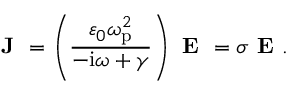<formula> <loc_0><loc_0><loc_500><loc_500>J = \left ( \frac { \varepsilon _ { 0 } \omega _ { p } ^ { 2 } } { - i \omega + \gamma } \right ) E = \sigma E .</formula> 